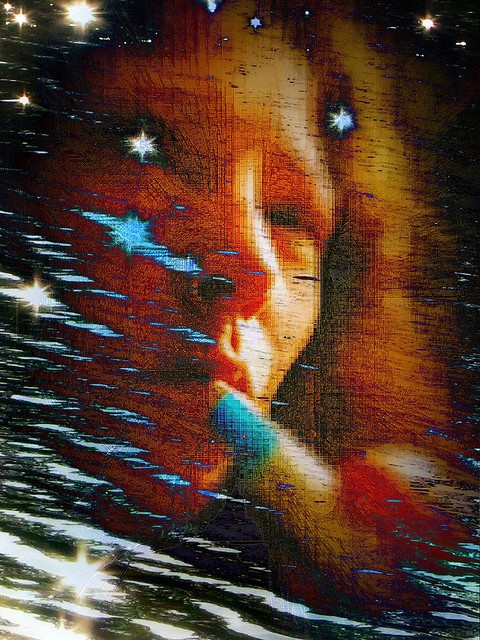Describe the objects in this image and their specific colors. I can see people in black, maroon, and brown tones and toothbrush in black, maroon, and olive tones in this image. 